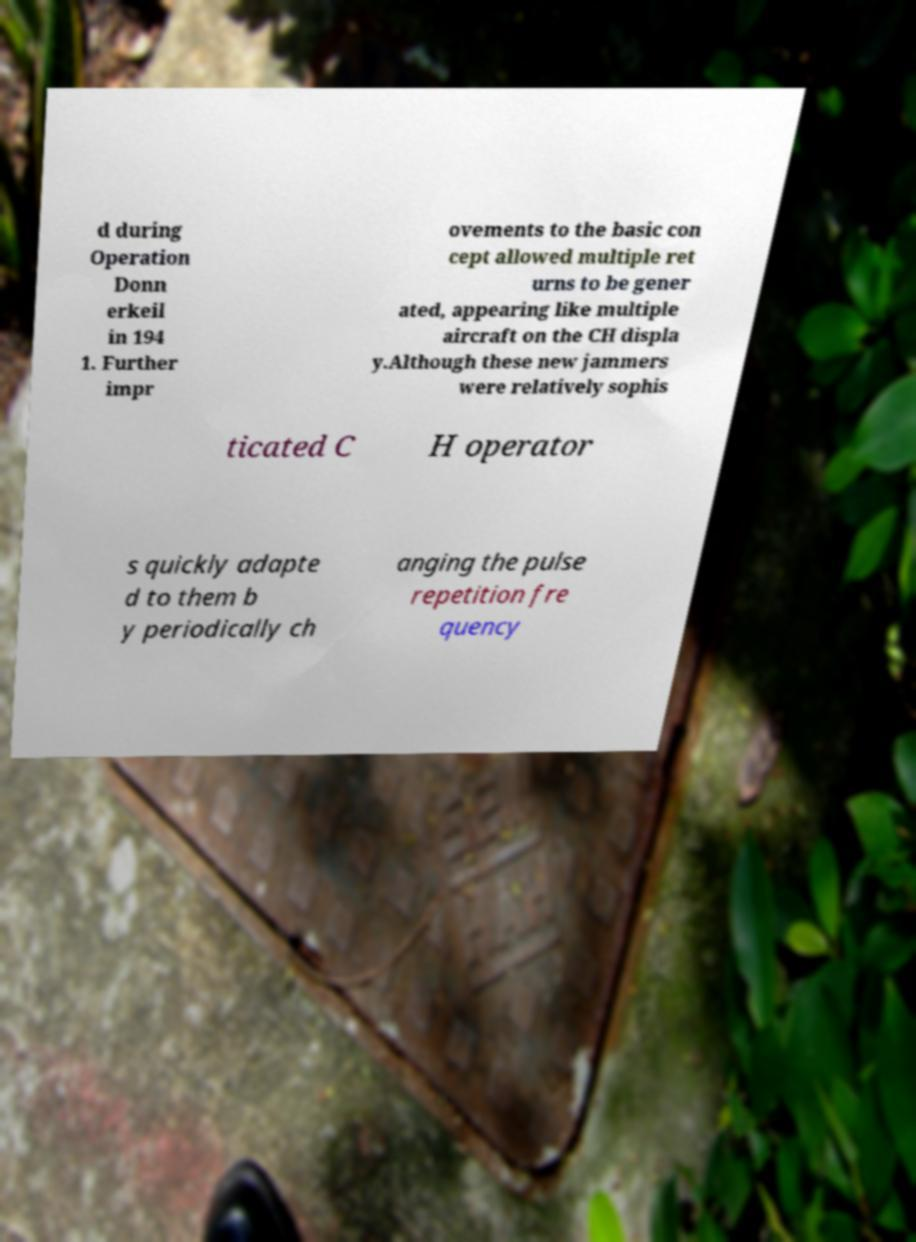Please read and relay the text visible in this image. What does it say? d during Operation Donn erkeil in 194 1. Further impr ovements to the basic con cept allowed multiple ret urns to be gener ated, appearing like multiple aircraft on the CH displa y.Although these new jammers were relatively sophis ticated C H operator s quickly adapte d to them b y periodically ch anging the pulse repetition fre quency 